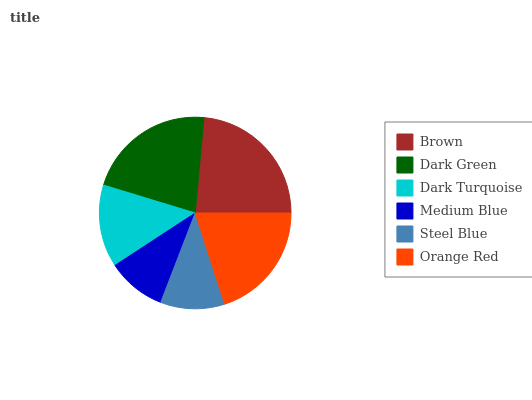Is Medium Blue the minimum?
Answer yes or no. Yes. Is Brown the maximum?
Answer yes or no. Yes. Is Dark Green the minimum?
Answer yes or no. No. Is Dark Green the maximum?
Answer yes or no. No. Is Brown greater than Dark Green?
Answer yes or no. Yes. Is Dark Green less than Brown?
Answer yes or no. Yes. Is Dark Green greater than Brown?
Answer yes or no. No. Is Brown less than Dark Green?
Answer yes or no. No. Is Orange Red the high median?
Answer yes or no. Yes. Is Dark Turquoise the low median?
Answer yes or no. Yes. Is Steel Blue the high median?
Answer yes or no. No. Is Orange Red the low median?
Answer yes or no. No. 